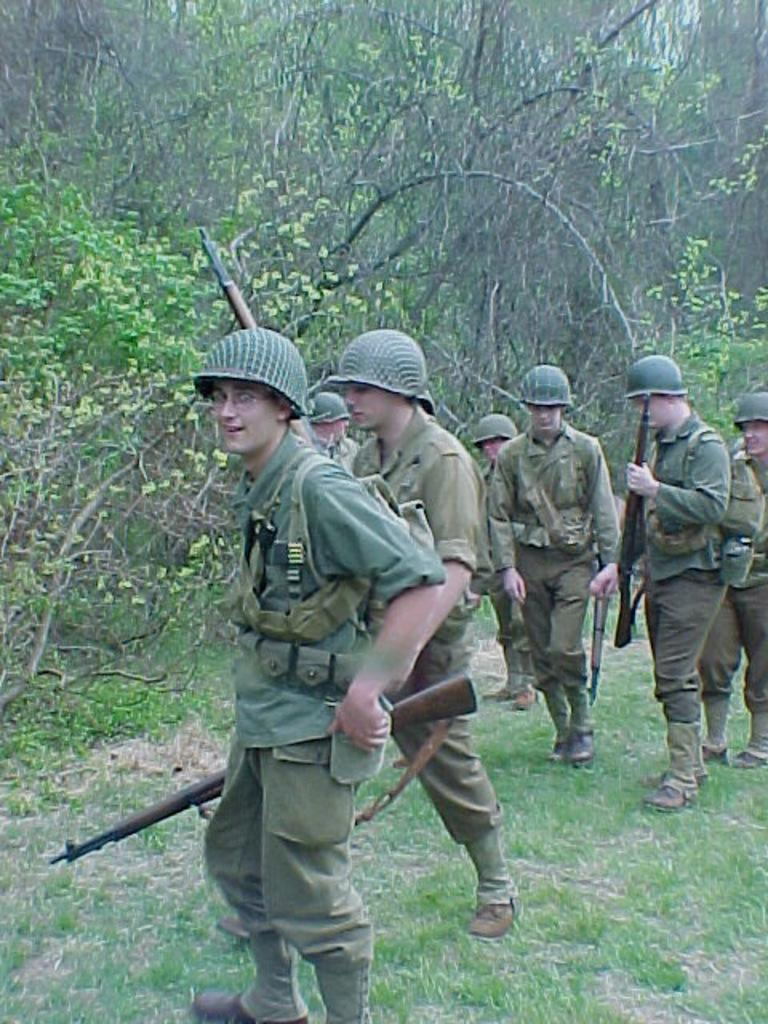What is the main subject of the image? The main subject of the image is a group of men. Where are the men located in the image? The men are standing on the ground in the image. What are the men wearing on their heads? The men are wearing helmets in the image. What are the men holding in their hands? The men are holding guns in the image. What type of vegetation is visible in the image? There is grass and a group of trees visible in the image. Where is the clock located in the image? There is no clock present in the image. What type of crook can be seen in the image? There is no crook present in the image. 